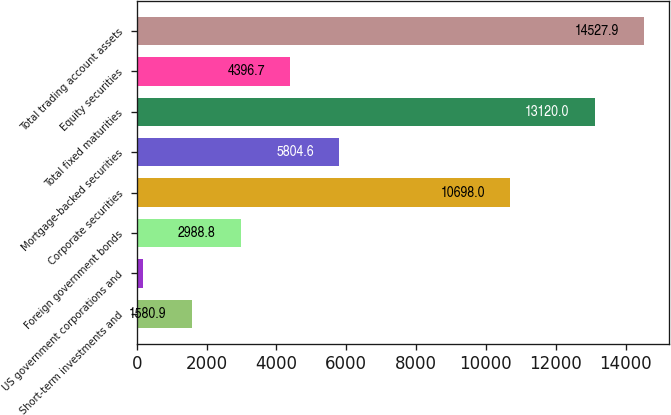<chart> <loc_0><loc_0><loc_500><loc_500><bar_chart><fcel>Short-term investments and<fcel>US government corporations and<fcel>Foreign government bonds<fcel>Corporate securities<fcel>Mortgage-backed securities<fcel>Total fixed maturities<fcel>Equity securities<fcel>Total trading account assets<nl><fcel>1580.9<fcel>173<fcel>2988.8<fcel>10698<fcel>5804.6<fcel>13120<fcel>4396.7<fcel>14527.9<nl></chart> 